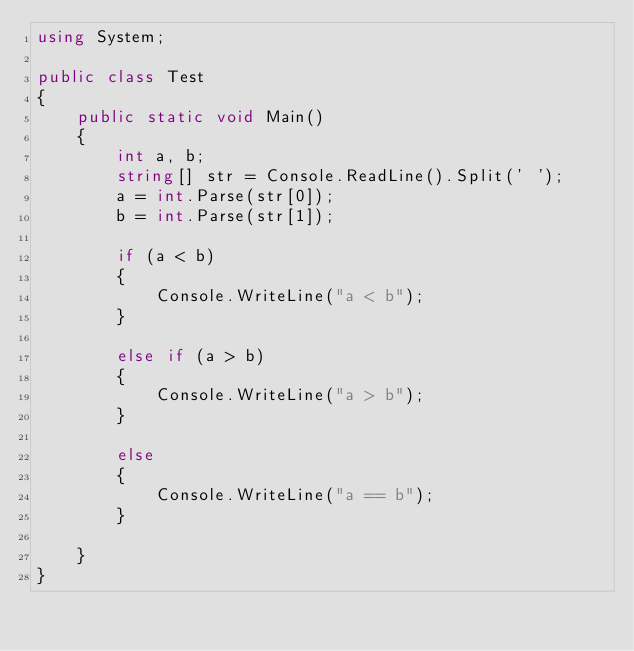<code> <loc_0><loc_0><loc_500><loc_500><_C#_>using System;

public class Test
{
    public static void Main()
    {
        int a, b;
        string[] str = Console.ReadLine().Split(' ');
        a = int.Parse(str[0]);
        b = int.Parse(str[1]);

        if (a < b)
        {
            Console.WriteLine("a < b");
        }

        else if (a > b)
        {
            Console.WriteLine("a > b");
        }

        else
        {
            Console.WriteLine("a == b");
        }

    }
}
</code> 